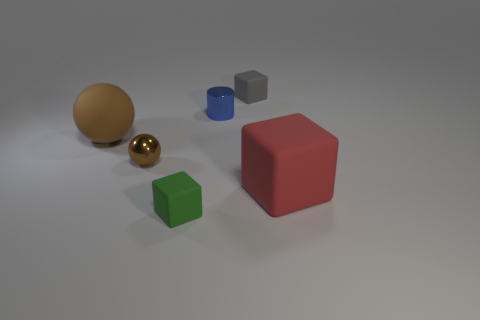Are there fewer small green objects that are behind the small green rubber block than tiny brown metallic balls right of the big brown rubber thing?
Make the answer very short. Yes. What is the color of the other tiny object that is made of the same material as the green object?
Keep it short and to the point. Gray. There is a matte cube behind the large red matte object; are there any tiny brown things that are right of it?
Your answer should be very brief. No. The cylinder that is the same size as the brown metallic ball is what color?
Give a very brief answer. Blue. What number of things are either tiny shiny cylinders or brown matte things?
Make the answer very short. 2. There is a brown sphere behind the brown thing that is in front of the matte object to the left of the green matte thing; how big is it?
Keep it short and to the point. Large. What number of large spheres have the same color as the tiny sphere?
Your answer should be very brief. 1. How many big cyan things have the same material as the tiny gray cube?
Offer a very short reply. 0. What number of things are small green things or tiny blocks that are in front of the red rubber object?
Keep it short and to the point. 1. The tiny matte block behind the block in front of the big matte object that is on the right side of the brown metal object is what color?
Your answer should be compact. Gray. 